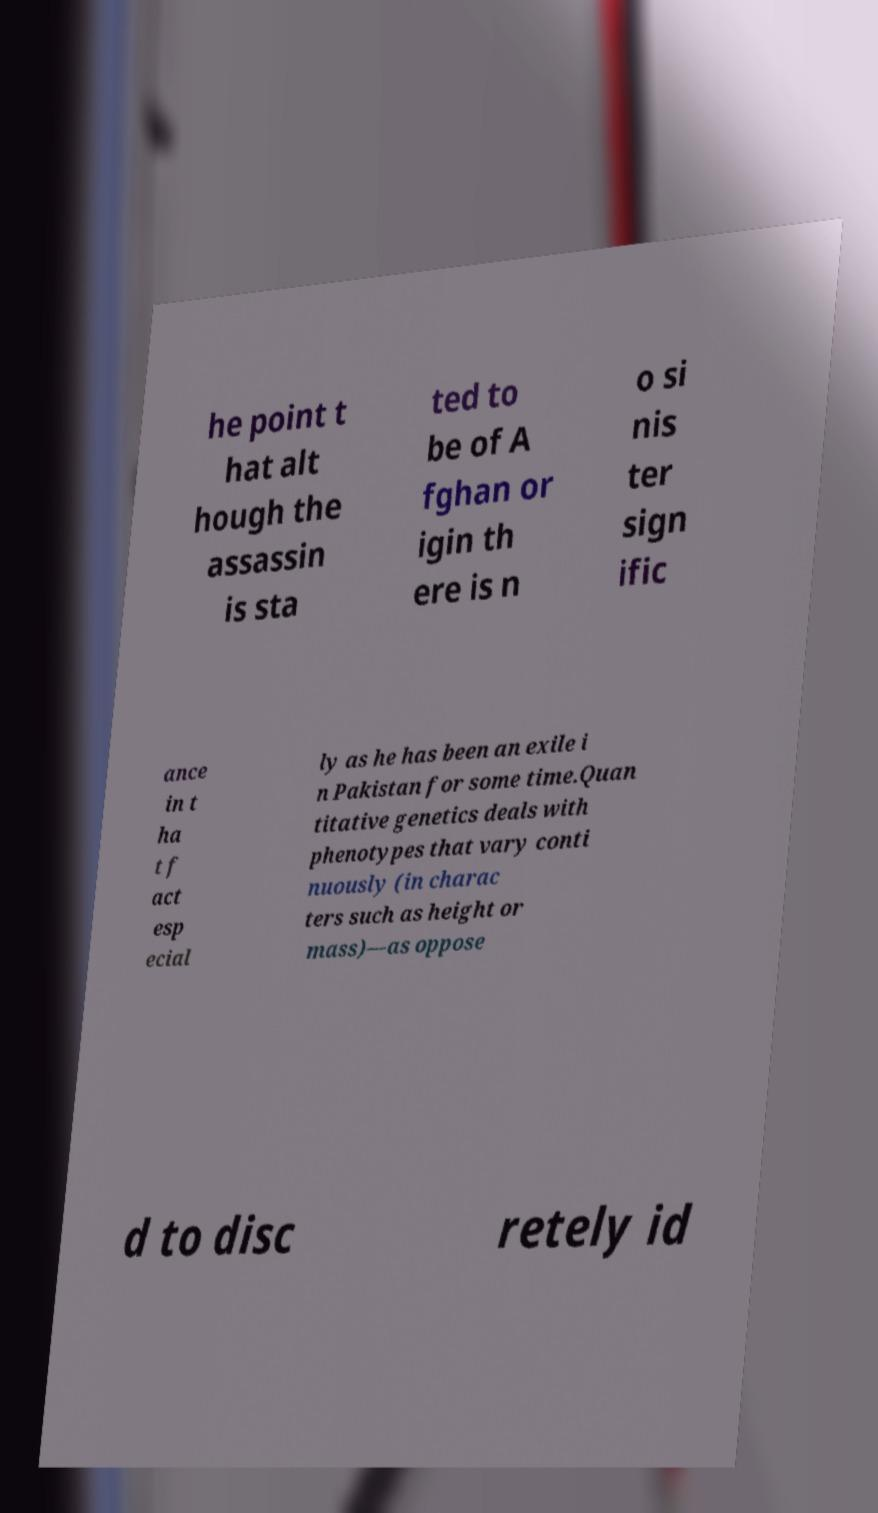Could you extract and type out the text from this image? he point t hat alt hough the assassin is sta ted to be of A fghan or igin th ere is n o si nis ter sign ific ance in t ha t f act esp ecial ly as he has been an exile i n Pakistan for some time.Quan titative genetics deals with phenotypes that vary conti nuously (in charac ters such as height or mass)—as oppose d to disc retely id 